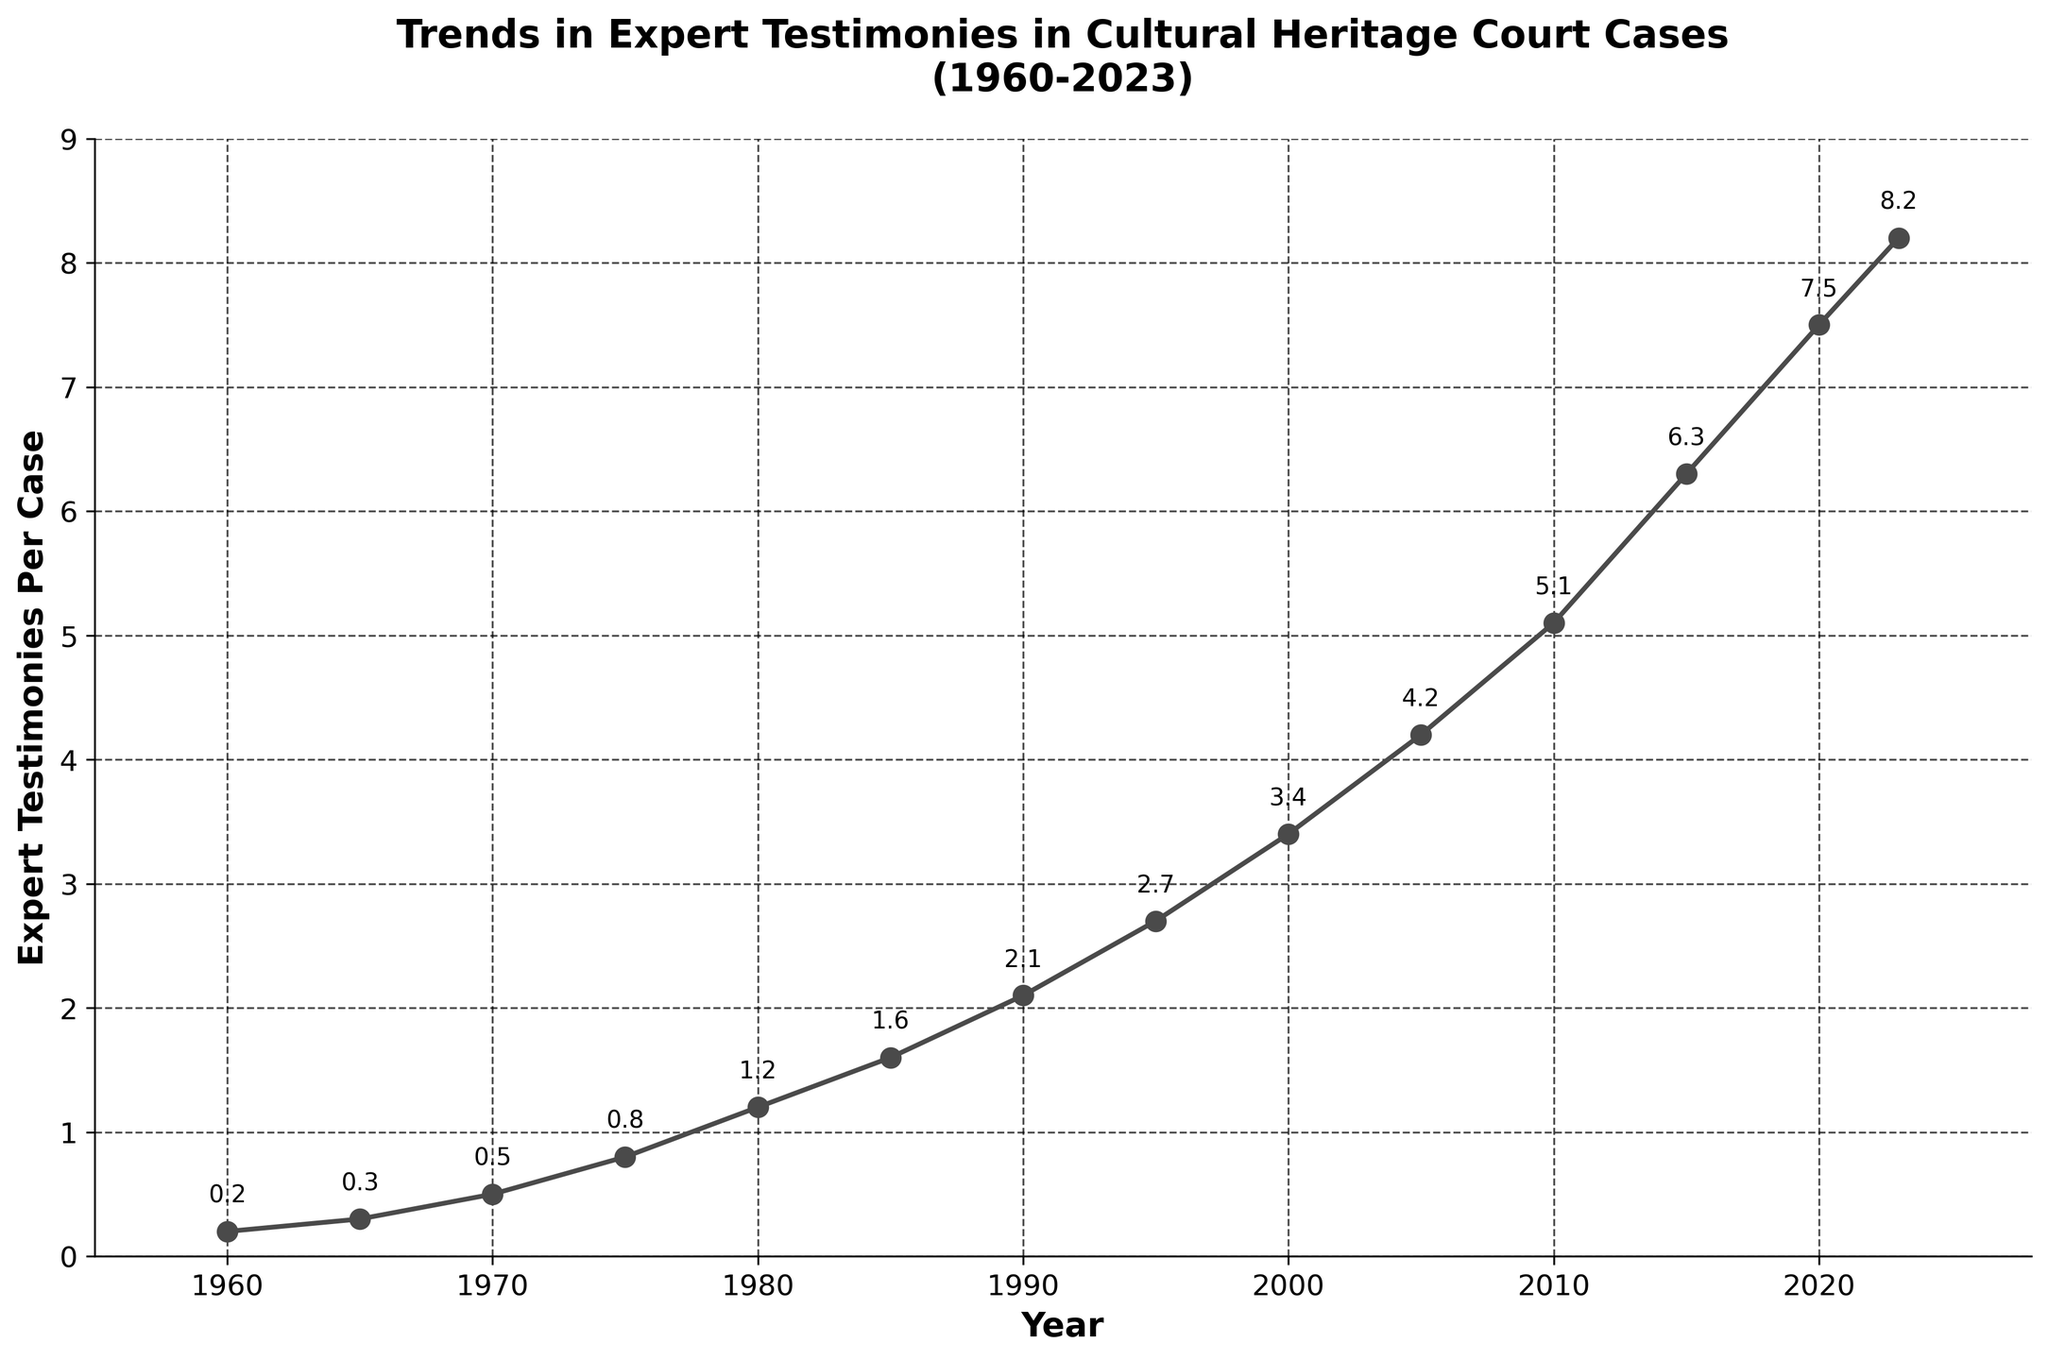What is the overall trend in the number of expert testimonies per case from 1960 to 2023? The figure shows a steady increase in the number of expert testimonies per case over time. Starting at 0.2 testimonies per case in 1960 and rising to 8.2 testimonies per case by 2023. This suggests a growing reliance on expert testimonies in cultural heritage court cases.
Answer: Steady increase By how much did the number of expert testimonies per case increase from 1970 to 2000? In 1970, the number of expert testimonies per case was 0.5. By 2000, it increased to 3.4. The difference is calculated as 3.4 - 0.5 = 2.9.
Answer: 2.9 Which decade saw the highest increase in expert testimonies per case? To find the decade with the highest increase, we calculate the increases for each decade. From 1960-1970, it's 0.5-0.2=0.3; 1970-1980, 1.2-0.5=0.7, and so on. The largest increase is from 2010-2020, where it goes from 6.3 to 7.5, an increase of 1.2.
Answer: 2010-2020 How many times more expert testimonies per case were there in 2023 compared to 1980? In 1980, there were 1.2 expert testimonies per case, and in 2023, there were 8.2. To find how many times more, divide 8.2 by 1.2, which is approximately 6.83 times more.
Answer: Approximately 6.83 times Compare the trend from 1960 to 1985 with the trend from 1985 to 2023. Which period saw a steeper increase? From 1960 to 1985, the increase is from 0.2 to 1.6 (1.4 over 25 years). From 1985 to 2023, the increase is from 1.6 to 8.2 (6.6 over 38 years). The second period saw a greater numeric increase, but to determine 'steeper', we consider the slope (increase per year): (1.4/25) = 0.056 for the first period, and (6.6/38) = 0.174 for the second period. The second period had a steeper increase.
Answer: 1985 to 2023 What is the average number of expert testimonies per case over the entire period (1960-2023)? Adding all the values from 1960 to 2023: 0.2 + 0.3 + 0.5 + 0.8 + 1.2 + 1.6 + 2.1 + 2.7 + 3.4 + 4.2 + 5.1 + 6.3 + 7.5 + 8.2 = 44.1. There are 14 data points, so the average is 44.1/14 = 3.15.
Answer: 3.15 What was the number of expert testimonies per case in 1990? The figure shows a data point at 1990 marked at 2.1 expert testimonies per case.
Answer: 2.1 In which year did the number of expert testimonies per case first exceed 5? The increase surpasses 5 expert testimonies per case in the year 2010, as shown by the data point at 2010 marked at 5.1.
Answer: 2010 Compare the growth rates in the periods 1960-1980 and 2000-2023. Which one had a higher growth rate? For 1960-1980, the number grew from 0.2 to 1.2, an increase of 1 over 20 years. For 2000-2023, the number grew from 3.4 to 8.2, an increase of 4.8 over 23 years. The growth rates are (1/20) = 0.05 per year and (4.8/23) ≈ 0.209 per year, respectively. The period 2000-2023 had a higher growth rate.
Answer: 2000-2023 